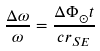<formula> <loc_0><loc_0><loc_500><loc_500>\frac { \Delta \omega } { \omega } = \frac { \Delta \Phi _ { \odot } t } { c r _ { S E } }</formula> 